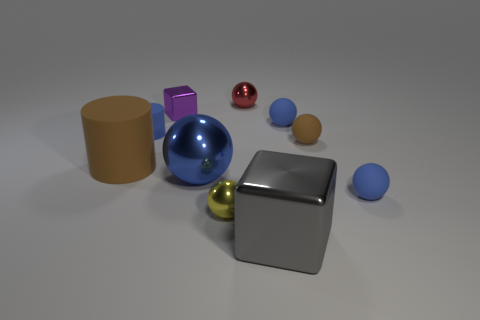Are there any other things that are the same shape as the tiny red thing?
Ensure brevity in your answer.  Yes. There is a tiny metal sphere behind the large metal object that is behind the large gray block; what color is it?
Your response must be concise. Red. What number of things are there?
Ensure brevity in your answer.  10. What number of metal objects are yellow spheres or small red things?
Provide a short and direct response. 2. How many rubber balls have the same color as the tiny metal block?
Your answer should be compact. 0. What is the blue sphere that is behind the large metal object left of the large gray metal cube made of?
Ensure brevity in your answer.  Rubber. What size is the purple cube?
Offer a terse response. Small. What number of brown matte cylinders are the same size as the blue metal ball?
Offer a terse response. 1. How many yellow things have the same shape as the small red metal thing?
Your answer should be compact. 1. Is the number of rubber objects that are to the left of the yellow thing the same as the number of tiny red balls?
Ensure brevity in your answer.  No. 